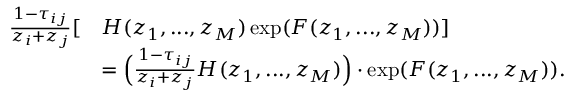Convert formula to latex. <formula><loc_0><loc_0><loc_500><loc_500>\begin{array} { r l } { \frac { 1 - \tau _ { i j } } { z _ { i } + z _ { j } } [ } & { H ( z _ { 1 } , \dots , z _ { M } ) \exp ( F ( z _ { 1 } , \dots , z _ { M } ) ) ] } \\ & { = \left ( \frac { 1 - \tau _ { i j } } { z _ { i } + z _ { j } } H ( z _ { 1 } , \dots , z _ { M } ) \right ) \cdot \exp ( F ( z _ { 1 } , \dots , z _ { M } ) ) . } \end{array}</formula> 